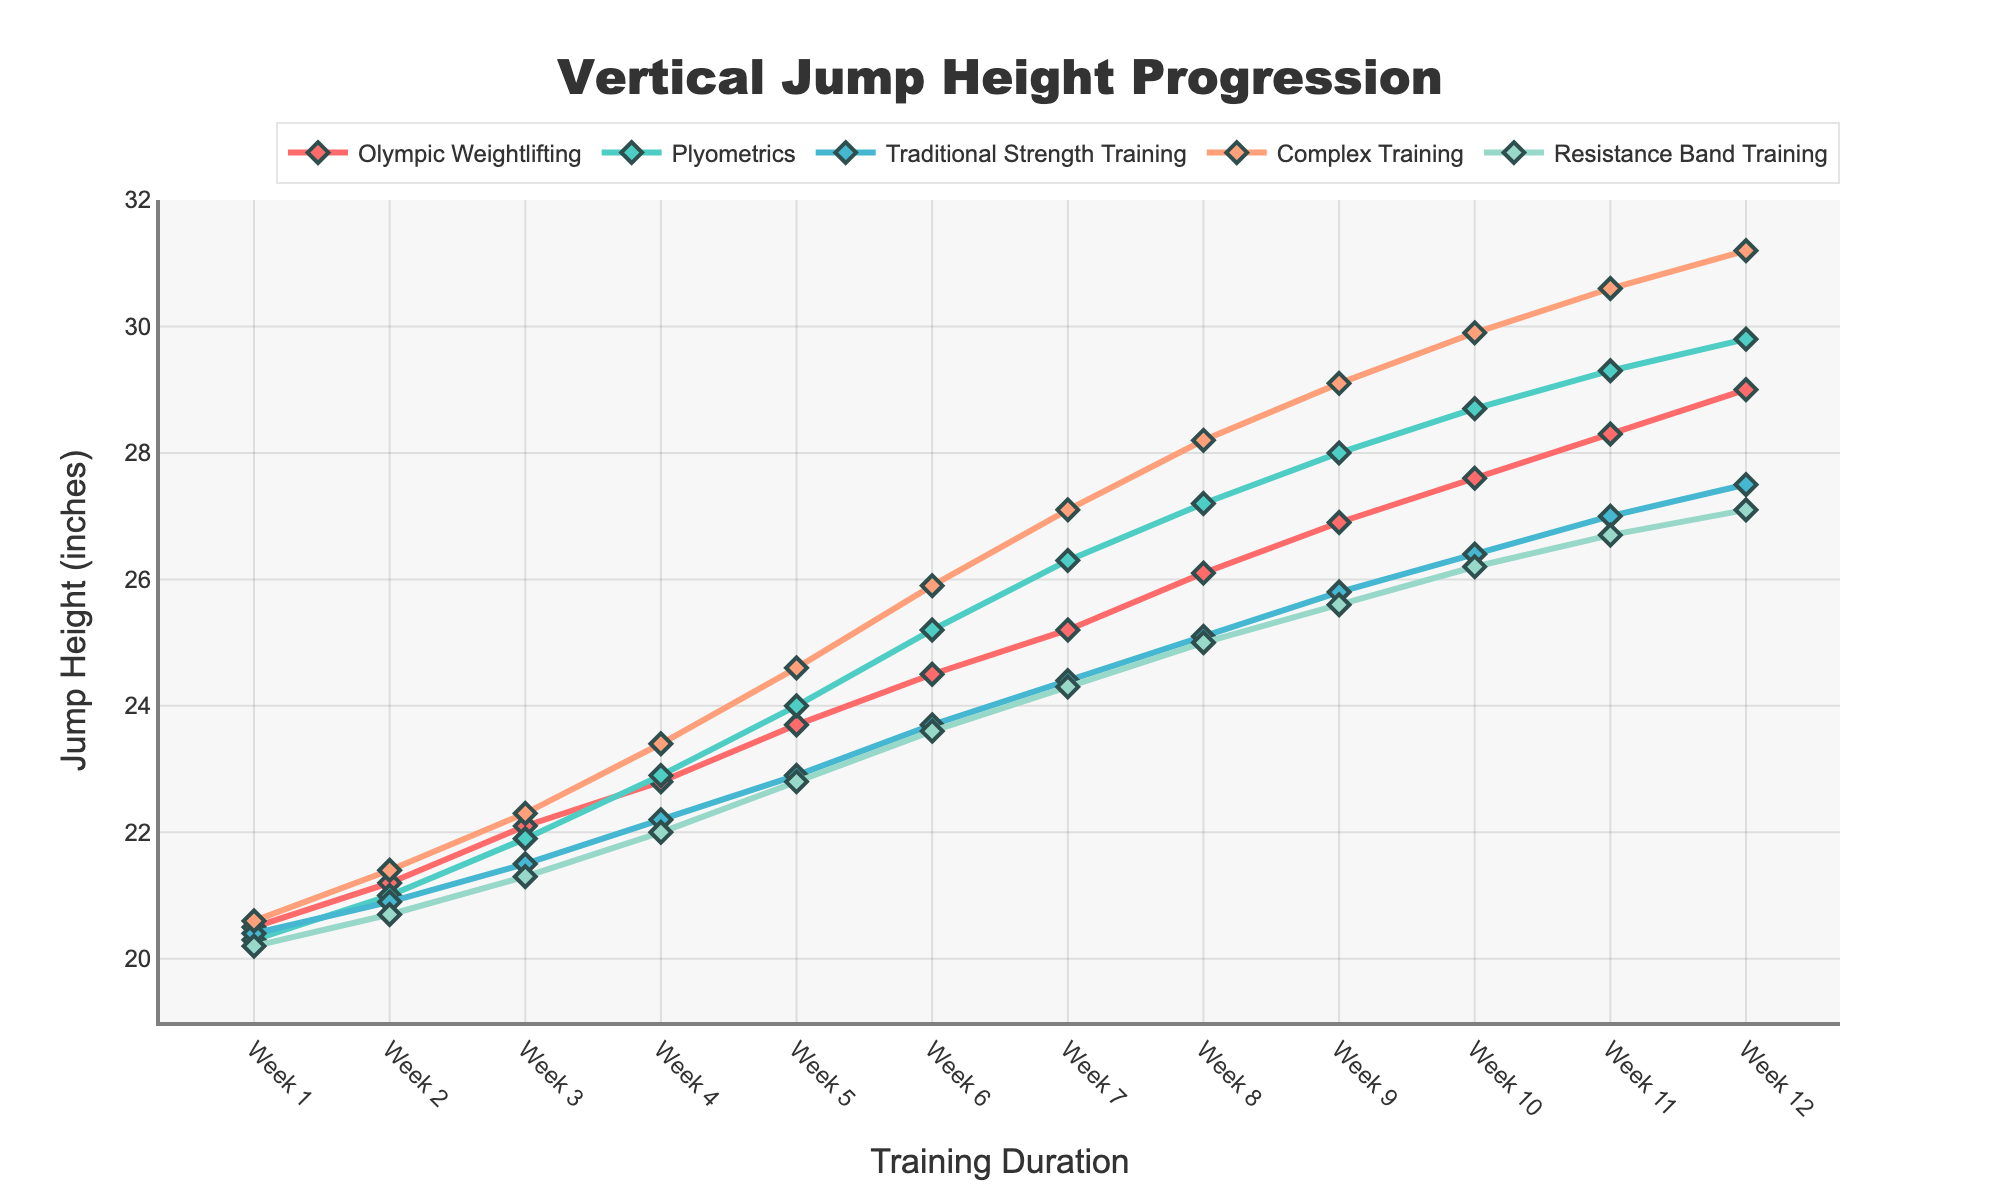What's the overall trend in vertical jump height for the Olympic Weightlifting program from Week 1 to Week 12? The vertical jump height for the Olympic Weightlifting program shows a consistent increasing trend from Week 1 (20.5 inches) to Week 12 (29.0 inches). This is observed by noting the steady incline of the line representing this program.
Answer: Consistent increase Which program had the highest jump height increase from Week 1 to Week 12? To find the program with the highest increase, we subtract the Week 1 value from the Week 12 value for each program. Olympic Weightlifting increased by 8.5 inches, Plyometrics by 9.5 inches, Traditional Strength Training by 7.1 inches, Complex Training by 10.6 inches, and Resistance Band Training by 6.9 inches. Complex Training has the highest jump height increase (31.2 - 20.6 = 10.6 inches).
Answer: Complex Training At Week 6, which program shows the greatest difference in jump height compared to the Resistance Band Training program? In Week 6, the Resistance Band Training program has a jump height of 23.6 inches. We compare this to Week 6 values of other programs: Olympic Weightlifting (24.5 inches), Plyometrics (25.2 inches), Traditional Strength Training (23.7 inches), Complex Training (25.9 inches). The greatest difference is 25.9 - 23.6 = 2.3 inches for Complex Training.
Answer: Complex Training How does the jump height progression of Plyometrics compare to Traditional Strength Training over the 12 weeks? Initially, Plyometrics (20.3 inches) and Traditional Strength Training (20.4 inches) start close in jump height. By Week 12, Plyometrics ends at 29.8 inches and Traditional Strength Training at 27.5 inches. Plyometrics consistently shows higher values and a steeper increase in jump height compared to Traditional Strength Training.
Answer: Plyometrics shows higher and steeper increase Between which weeks does Complex Training show the largest single week jump increase? To find this, we look at the increments in the Complex Training program: Week 1-2 (0.8), Week 2-3 (0.9), Week 3-4 (1.1), Week 4-5 (1.2), Week 5-6 (1.3), Week 6-7 (1.2), Week 7-8 (1.1), Week 8-9 (0.9), Week 9-10 (0.8), Week 10-11 (0.7), Week 11-12 (0.6). The largest increase is between Week 5-6 with a change of 1.3 inches.
Answer: Week 5-6 What is the average jump height in Week 8 across all programs? To find the average, sum the jump heights for all programs in Week 8 and divide by the number of programs: (26.1 + 27.2 + 25.1 + 28.2 + 25.0) / 5. This equals (131.6 / 5) = 26.32 inches.
Answer: 26.32 inches Which program has the least variability in jump height change across all 12 weeks? Variability can be judged by the steadiness and length of the line. Traditional Strength Training and Resistance Band Training show relatively steady increases without large fluctuations. Comparing the range (max - min): Traditional Strength Training (27.5 - 20.4 = 7.1), Resistance Band Training (27.1 - 20.2 = 6.9). Resistance Band Training has the least variability with 6.9 inches.
Answer: Resistance Band Training 